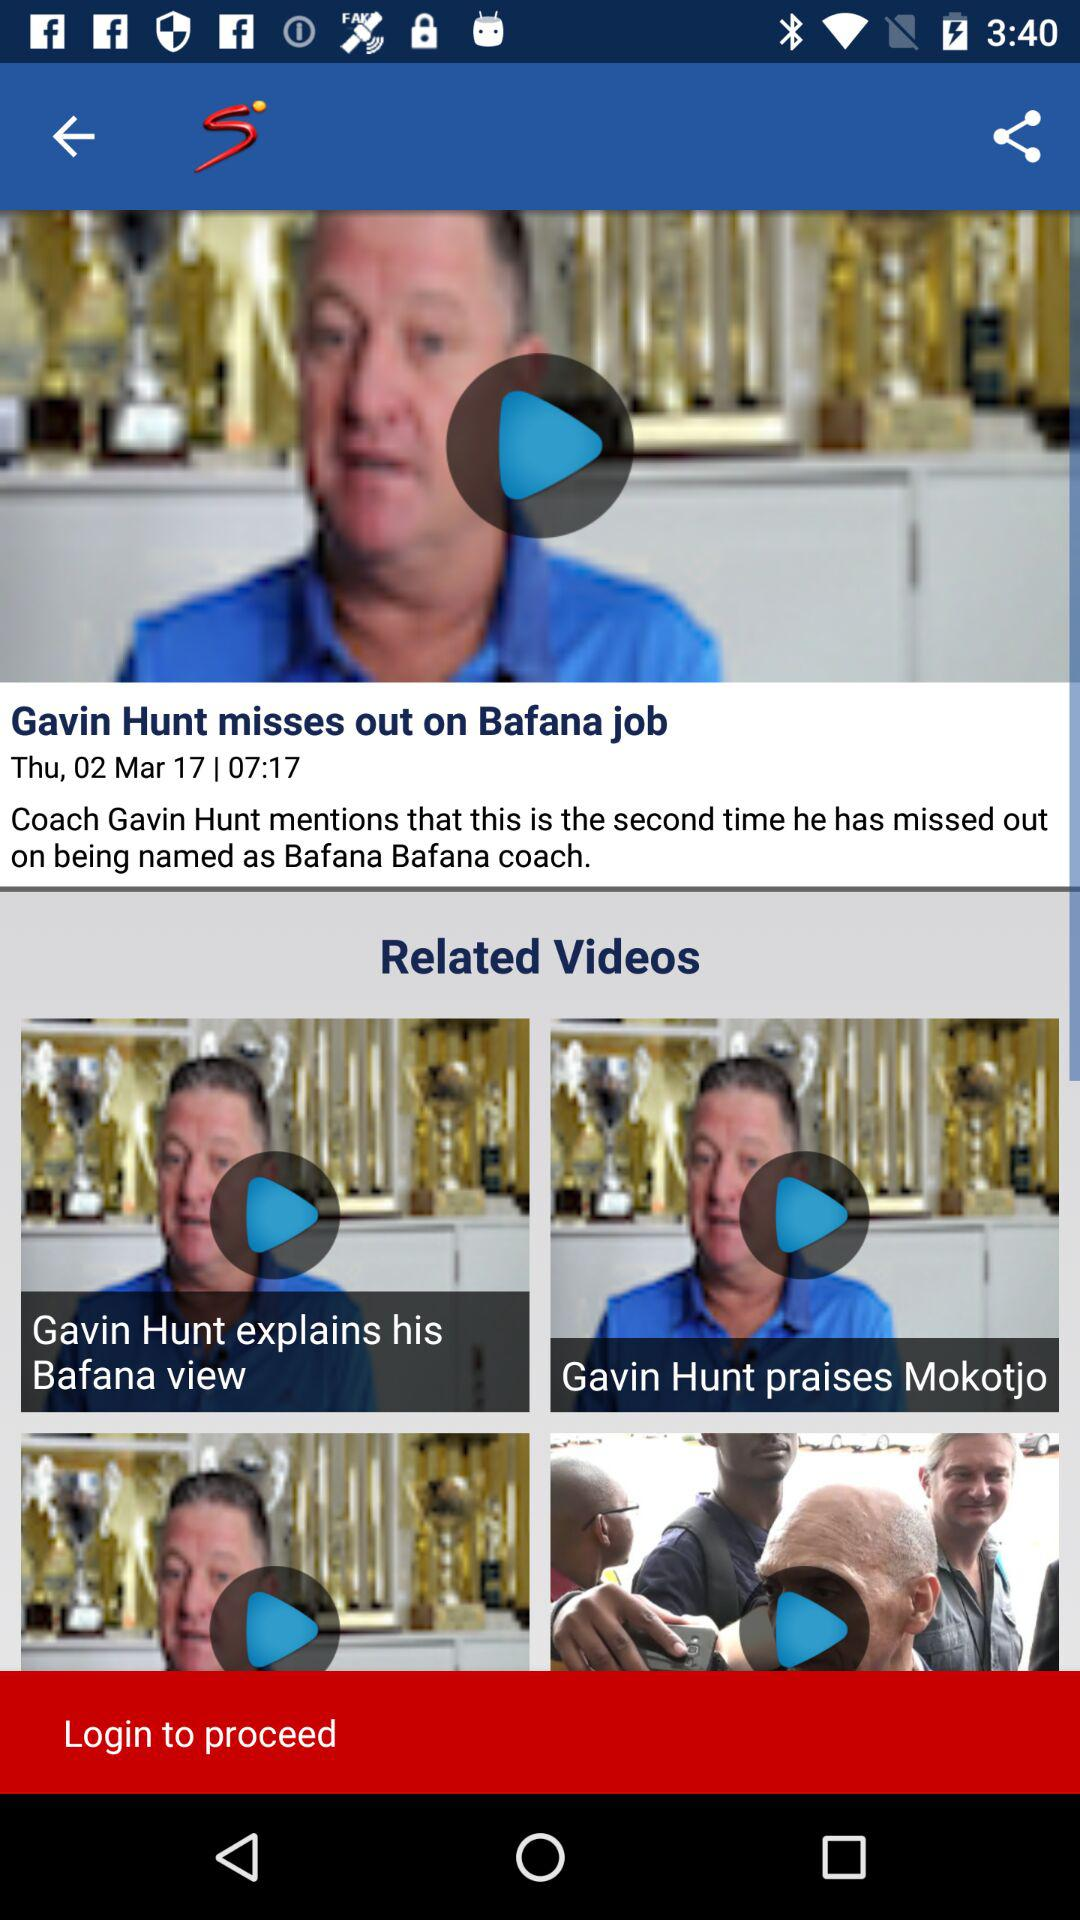When was the news "Gavin Hunt misses out on Bafana job" posted? The news was posted on Thursday, March 2, 2017 at 07:17. 